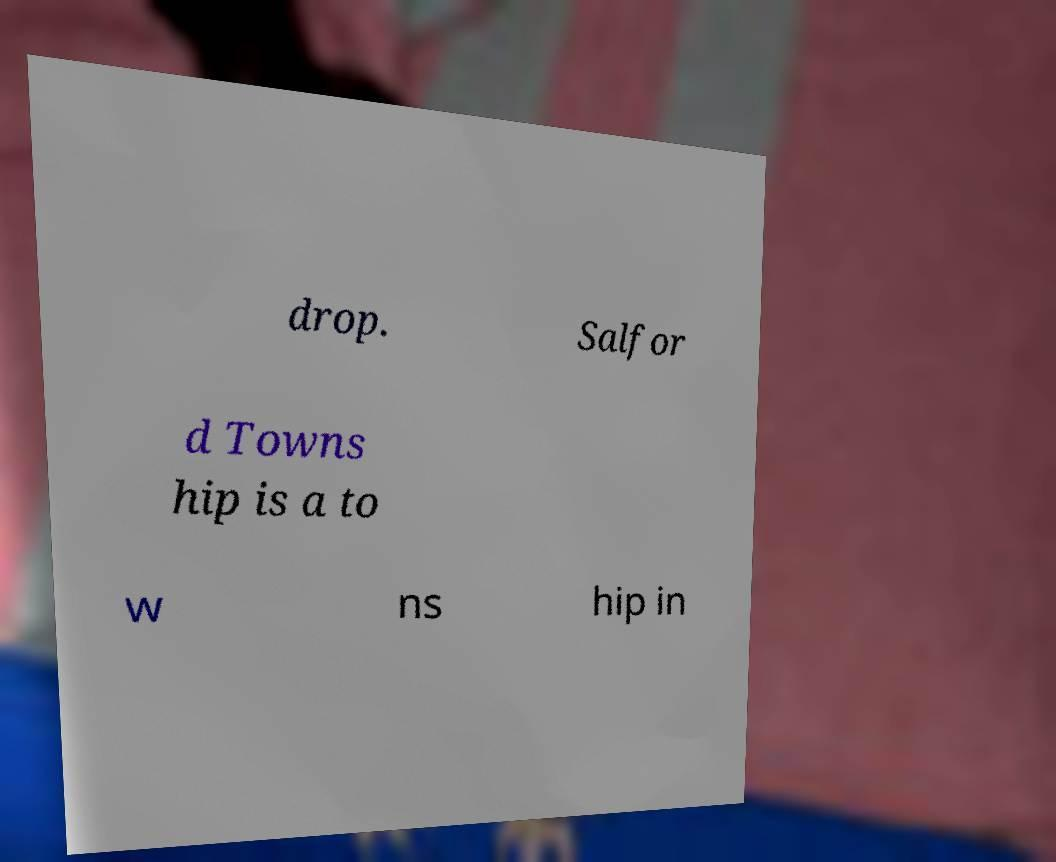I need the written content from this picture converted into text. Can you do that? drop. Salfor d Towns hip is a to w ns hip in 